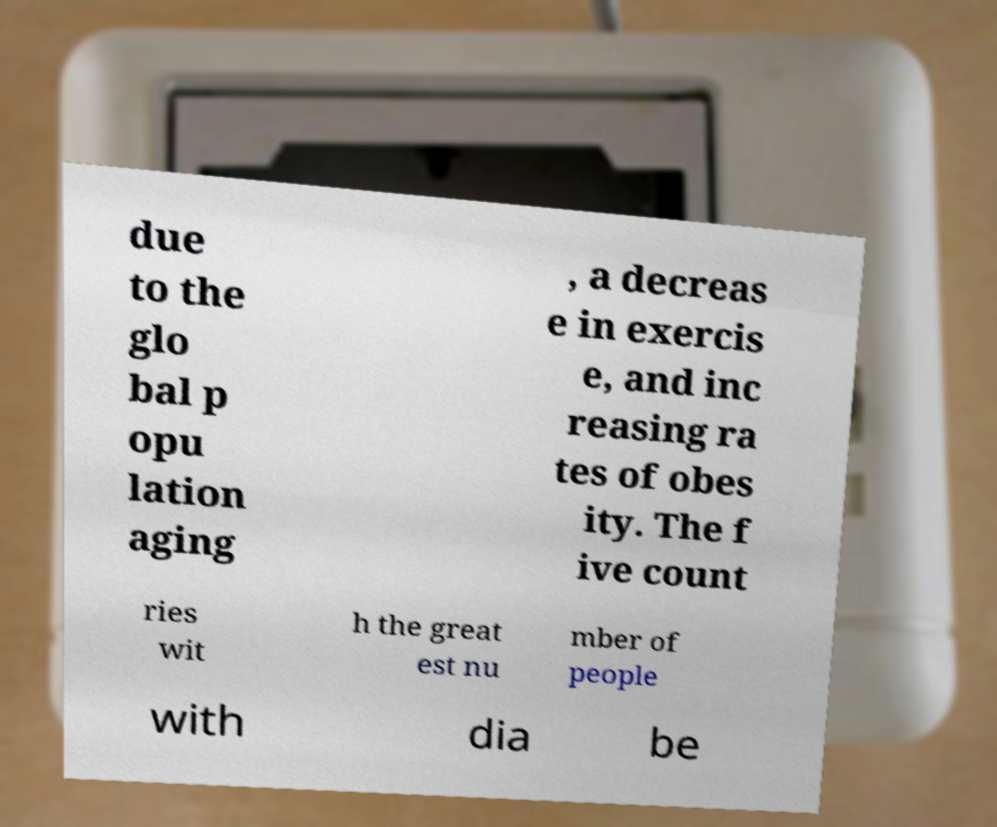Could you assist in decoding the text presented in this image and type it out clearly? due to the glo bal p opu lation aging , a decreas e in exercis e, and inc reasing ra tes of obes ity. The f ive count ries wit h the great est nu mber of people with dia be 